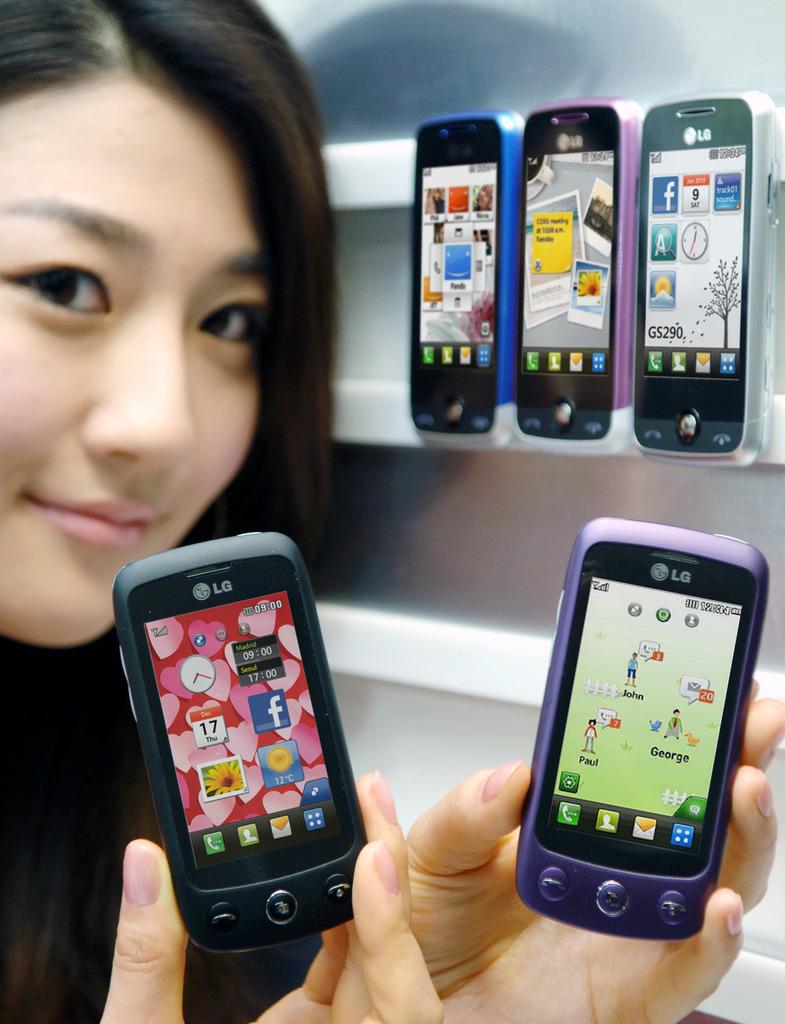What brand are these phones?
Your response must be concise. Lg. What day is it according to the phone on the left?
Provide a succinct answer. Thursday. 